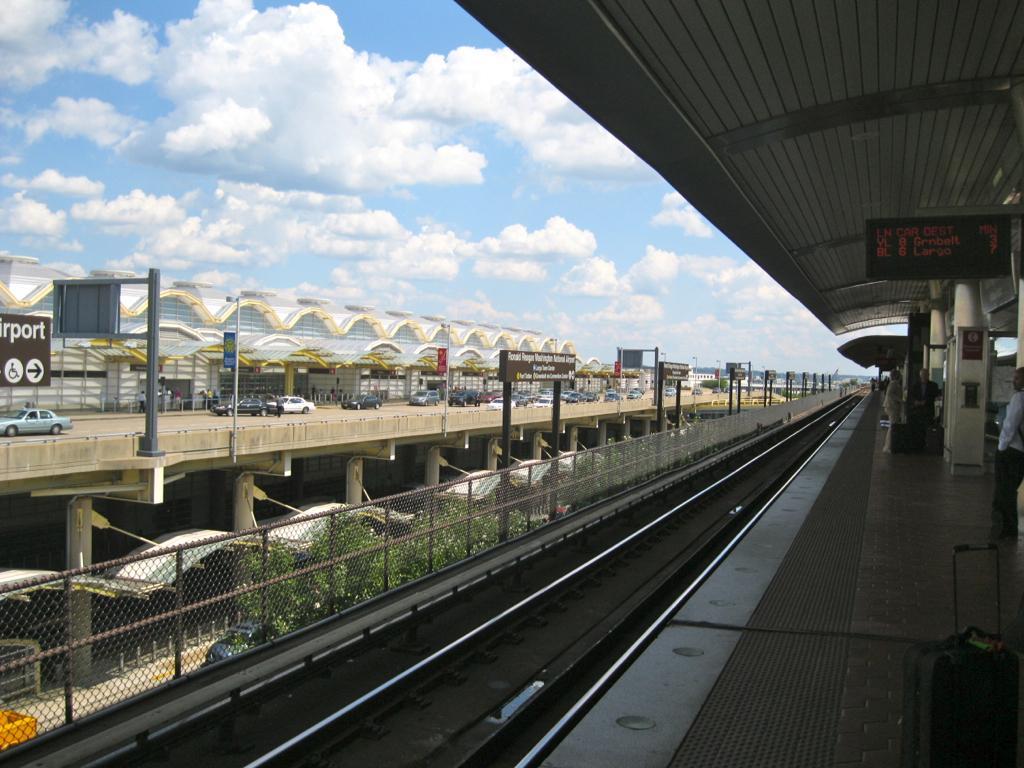Describe this image in one or two sentences. This picture shows a railway track and we see a platform and a display Board and we see few people standing and we see a airport building on the side and few cars and name boards with text and a blue cloudy Sky and we see trees. 